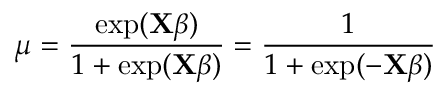<formula> <loc_0><loc_0><loc_500><loc_500>\mu = { \frac { \exp ( X { \beta } ) } { 1 + \exp ( X { \beta } ) } } = { \frac { 1 } { 1 + \exp ( - X { \beta } ) } } \,</formula> 